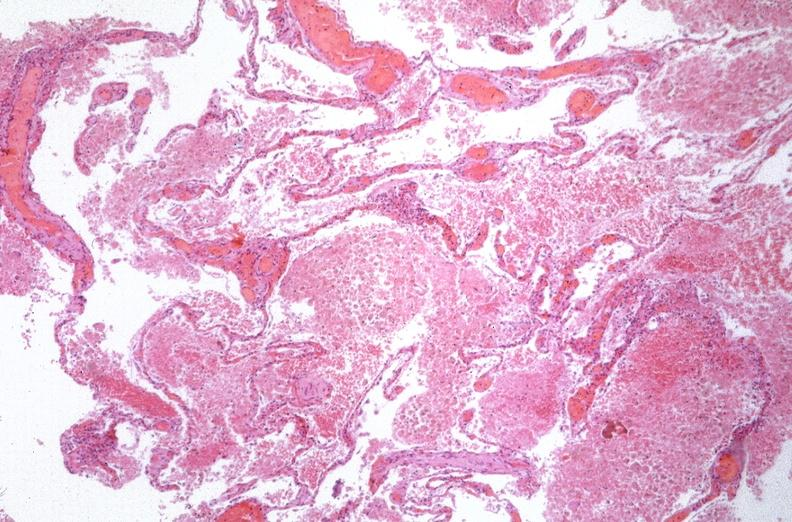does von show lung, emphysema and pneumonia, alpha-1 antitrypsin deficiency?
Answer the question using a single word or phrase. No 